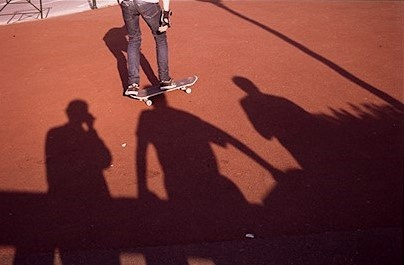Describe the objects in this image and their specific colors. I can see people in salmon, black, maroon, and brown tones, people in salmon, brown, and maroon tones, and skateboard in salmon, brown, black, maroon, and lightgray tones in this image. 